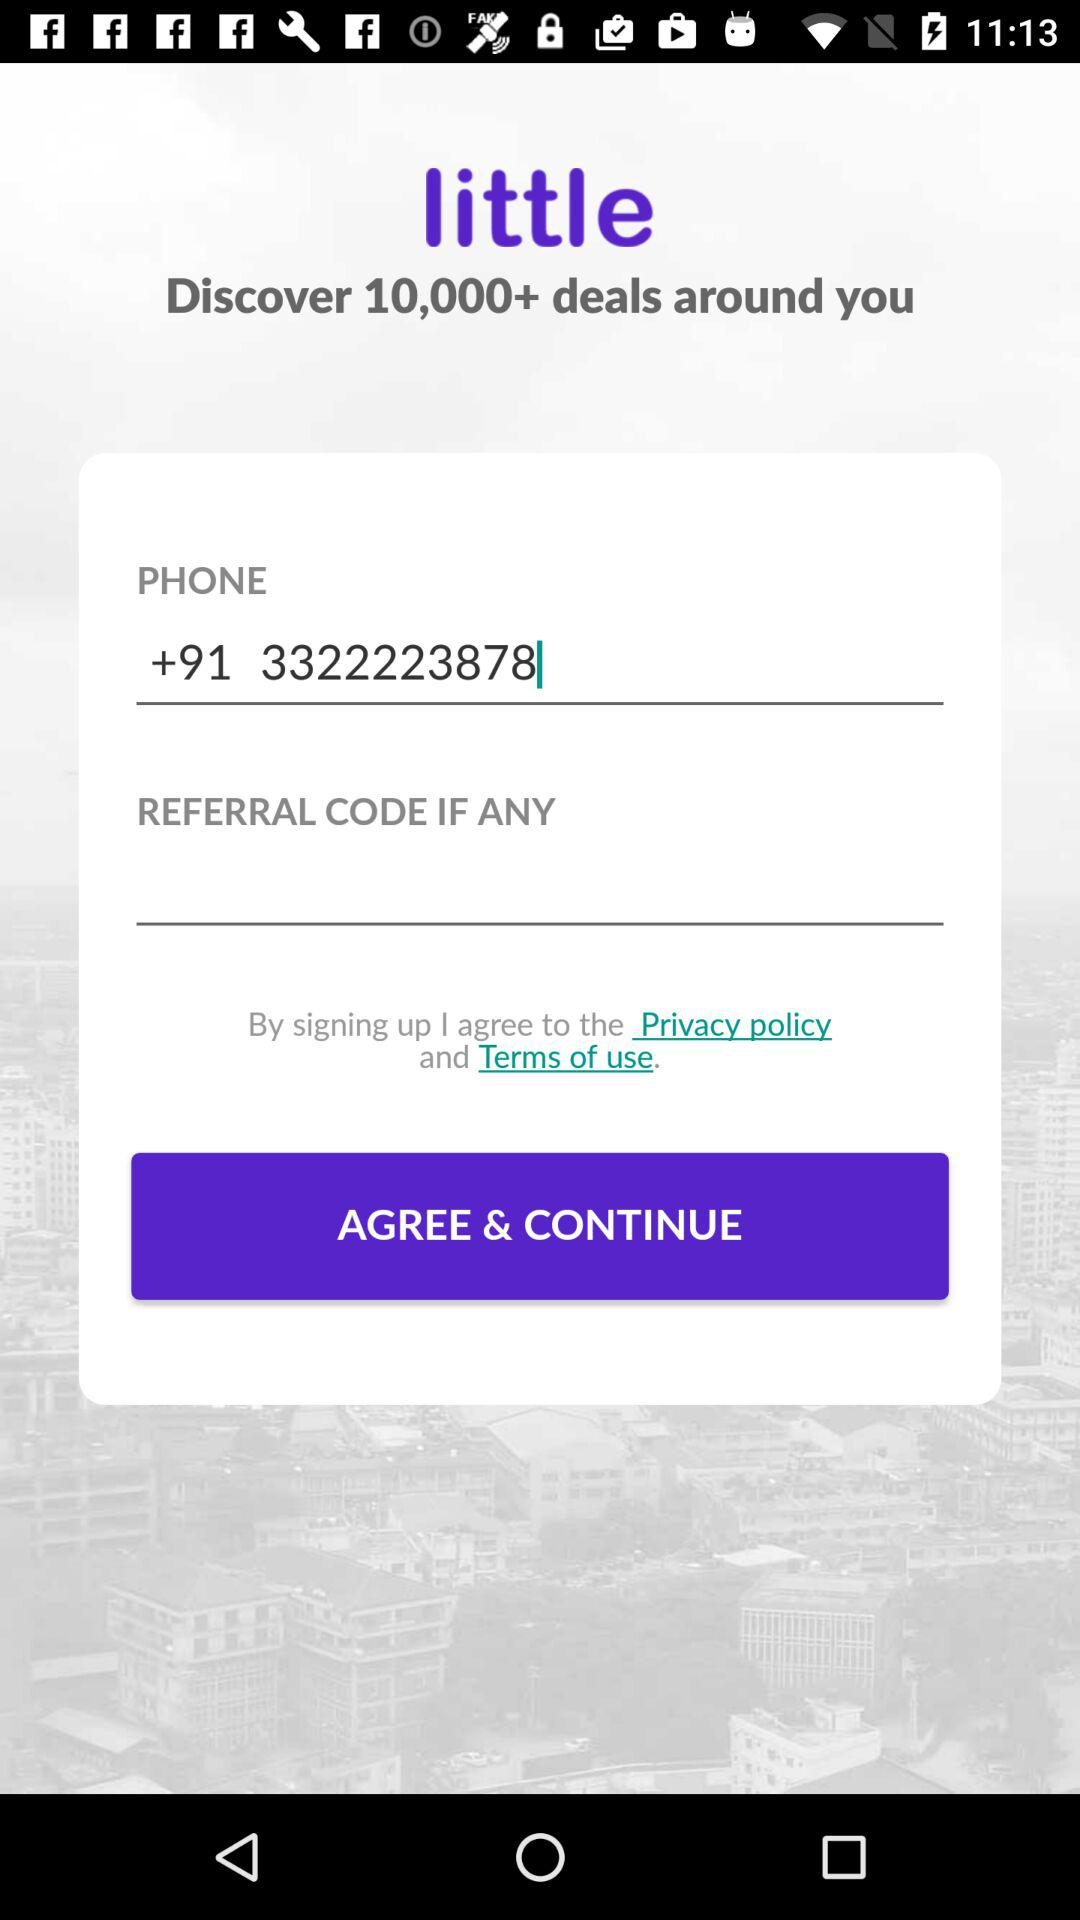What is the code for the country? The code is +91. 